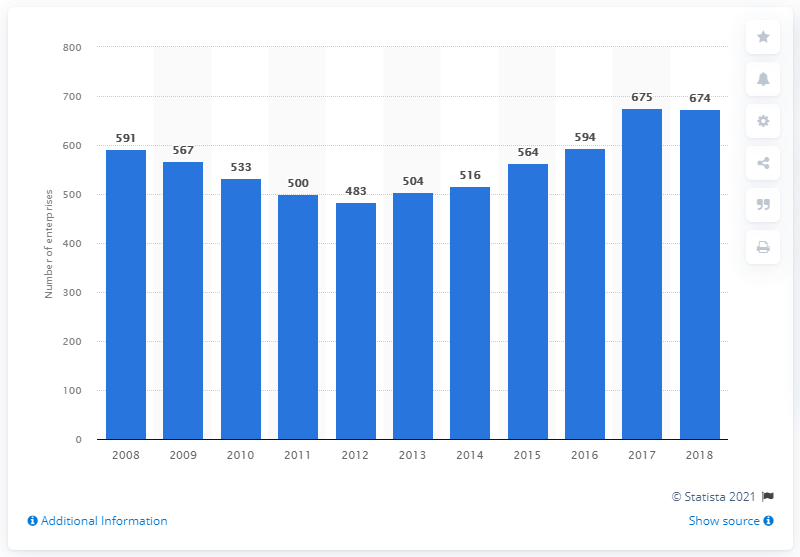Give some essential details in this illustration. In 2018, there were 674 UK manufacturers specializing in games and toys. 